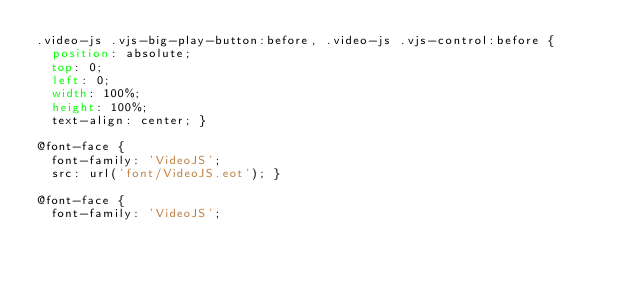<code> <loc_0><loc_0><loc_500><loc_500><_CSS_>.video-js .vjs-big-play-button:before, .video-js .vjs-control:before {
  position: absolute;
  top: 0;
  left: 0;
  width: 100%;
  height: 100%;
  text-align: center; }

@font-face {
  font-family: 'VideoJS';
  src: url('font/VideoJS.eot'); }

@font-face {
  font-family: 'VideoJS';</code> 